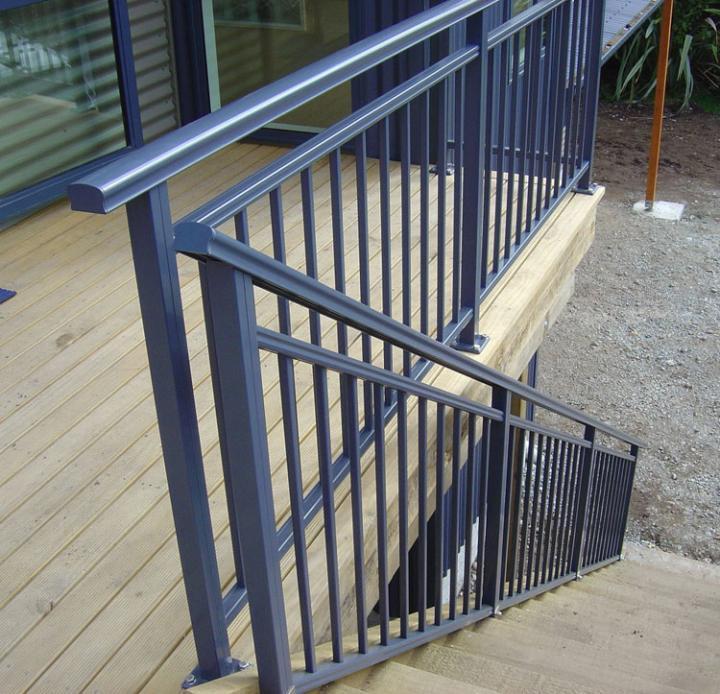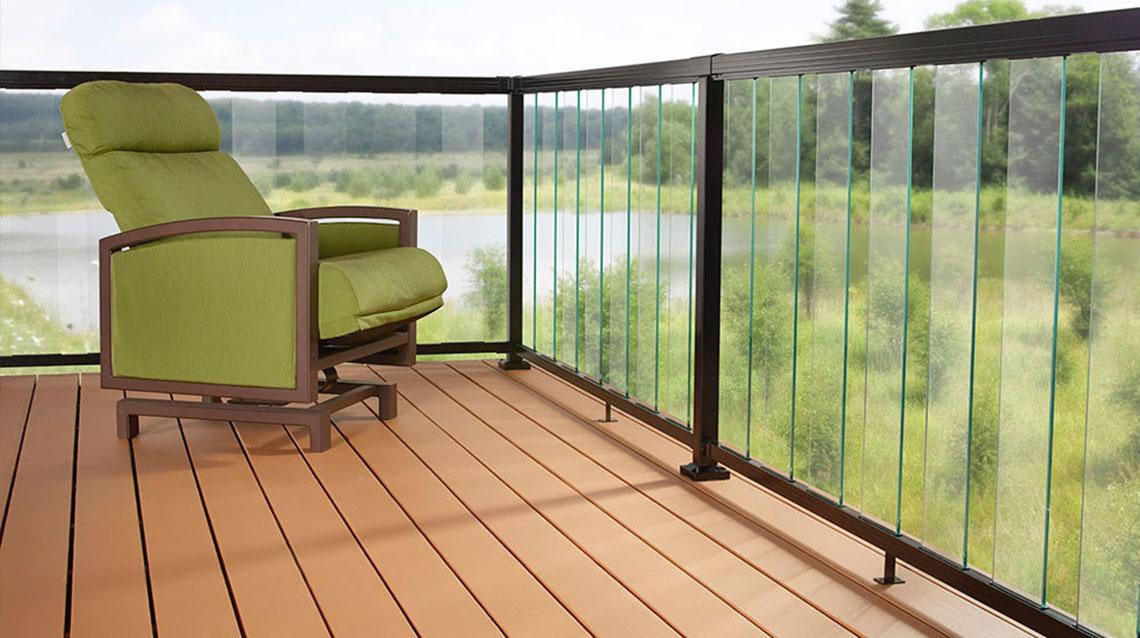The first image is the image on the left, the second image is the image on the right. Assess this claim about the two images: "There is a glass railing.". Correct or not? Answer yes or no. Yes. The first image is the image on the left, the second image is the image on the right. Considering the images on both sides, is "A balcony has a glass fence in one of the images." valid? Answer yes or no. Yes. 